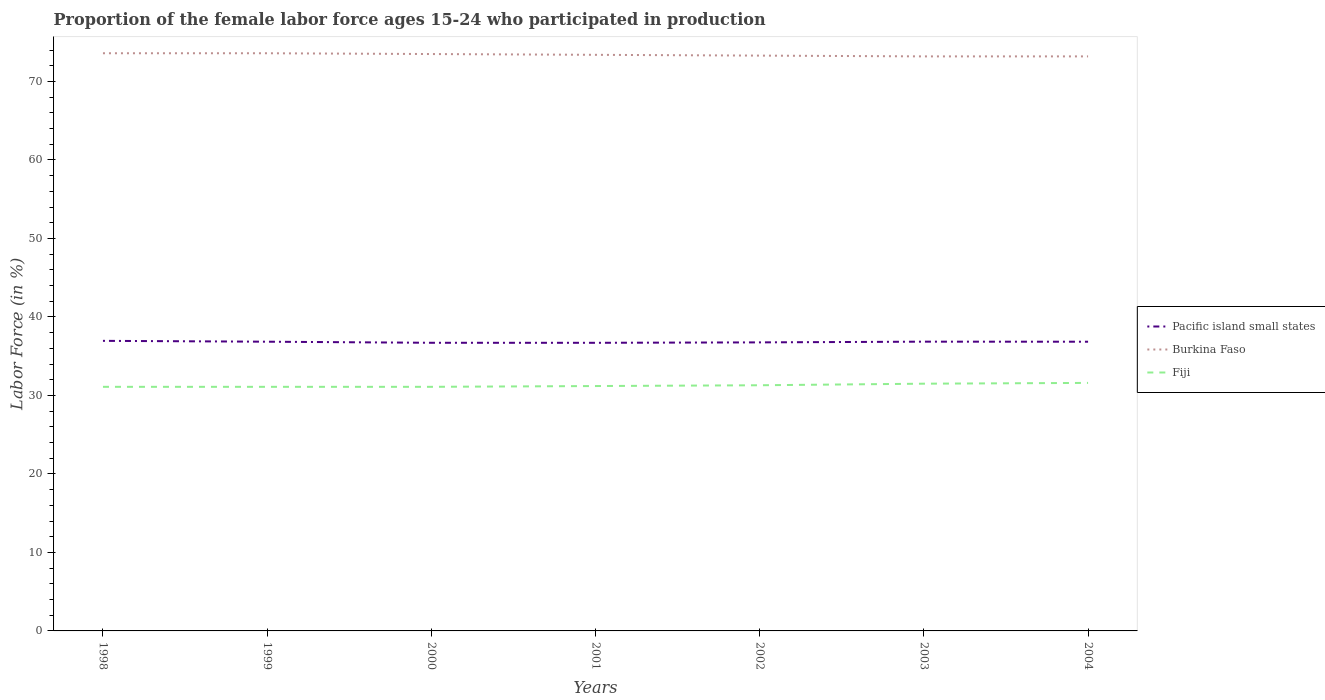How many different coloured lines are there?
Your response must be concise. 3. Across all years, what is the maximum proportion of the female labor force who participated in production in Pacific island small states?
Provide a short and direct response. 36.71. What is the total proportion of the female labor force who participated in production in Pacific island small states in the graph?
Your answer should be compact. 0.01. What is the difference between the highest and the second highest proportion of the female labor force who participated in production in Pacific island small states?
Offer a very short reply. 0.25. Is the proportion of the female labor force who participated in production in Pacific island small states strictly greater than the proportion of the female labor force who participated in production in Burkina Faso over the years?
Your answer should be compact. Yes. Does the graph contain any zero values?
Your answer should be very brief. No. Does the graph contain grids?
Offer a terse response. No. How are the legend labels stacked?
Provide a short and direct response. Vertical. What is the title of the graph?
Offer a terse response. Proportion of the female labor force ages 15-24 who participated in production. What is the label or title of the Y-axis?
Give a very brief answer. Labor Force (in %). What is the Labor Force (in %) in Pacific island small states in 1998?
Give a very brief answer. 36.96. What is the Labor Force (in %) of Burkina Faso in 1998?
Ensure brevity in your answer.  73.6. What is the Labor Force (in %) of Fiji in 1998?
Offer a very short reply. 31.1. What is the Labor Force (in %) in Pacific island small states in 1999?
Your answer should be very brief. 36.85. What is the Labor Force (in %) of Burkina Faso in 1999?
Keep it short and to the point. 73.6. What is the Labor Force (in %) in Fiji in 1999?
Provide a short and direct response. 31.1. What is the Labor Force (in %) of Pacific island small states in 2000?
Offer a terse response. 36.71. What is the Labor Force (in %) in Burkina Faso in 2000?
Offer a very short reply. 73.5. What is the Labor Force (in %) of Fiji in 2000?
Your response must be concise. 31.1. What is the Labor Force (in %) of Pacific island small states in 2001?
Provide a succinct answer. 36.71. What is the Labor Force (in %) in Burkina Faso in 2001?
Make the answer very short. 73.4. What is the Labor Force (in %) of Fiji in 2001?
Your response must be concise. 31.2. What is the Labor Force (in %) in Pacific island small states in 2002?
Offer a very short reply. 36.76. What is the Labor Force (in %) of Burkina Faso in 2002?
Offer a very short reply. 73.3. What is the Labor Force (in %) in Fiji in 2002?
Your answer should be compact. 31.3. What is the Labor Force (in %) in Pacific island small states in 2003?
Your response must be concise. 36.85. What is the Labor Force (in %) in Burkina Faso in 2003?
Keep it short and to the point. 73.2. What is the Labor Force (in %) in Fiji in 2003?
Ensure brevity in your answer.  31.5. What is the Labor Force (in %) in Pacific island small states in 2004?
Ensure brevity in your answer.  36.85. What is the Labor Force (in %) in Burkina Faso in 2004?
Your answer should be very brief. 73.2. What is the Labor Force (in %) in Fiji in 2004?
Provide a succinct answer. 31.6. Across all years, what is the maximum Labor Force (in %) in Pacific island small states?
Ensure brevity in your answer.  36.96. Across all years, what is the maximum Labor Force (in %) in Burkina Faso?
Offer a terse response. 73.6. Across all years, what is the maximum Labor Force (in %) of Fiji?
Keep it short and to the point. 31.6. Across all years, what is the minimum Labor Force (in %) of Pacific island small states?
Offer a very short reply. 36.71. Across all years, what is the minimum Labor Force (in %) in Burkina Faso?
Make the answer very short. 73.2. Across all years, what is the minimum Labor Force (in %) of Fiji?
Make the answer very short. 31.1. What is the total Labor Force (in %) in Pacific island small states in the graph?
Offer a very short reply. 257.69. What is the total Labor Force (in %) of Burkina Faso in the graph?
Provide a short and direct response. 513.8. What is the total Labor Force (in %) of Fiji in the graph?
Offer a very short reply. 218.9. What is the difference between the Labor Force (in %) in Pacific island small states in 1998 and that in 1999?
Your answer should be very brief. 0.11. What is the difference between the Labor Force (in %) of Pacific island small states in 1998 and that in 2000?
Your answer should be very brief. 0.25. What is the difference between the Labor Force (in %) of Pacific island small states in 1998 and that in 2001?
Give a very brief answer. 0.25. What is the difference between the Labor Force (in %) of Pacific island small states in 1998 and that in 2002?
Provide a succinct answer. 0.2. What is the difference between the Labor Force (in %) in Burkina Faso in 1998 and that in 2002?
Offer a very short reply. 0.3. What is the difference between the Labor Force (in %) of Fiji in 1998 and that in 2002?
Give a very brief answer. -0.2. What is the difference between the Labor Force (in %) of Pacific island small states in 1998 and that in 2003?
Ensure brevity in your answer.  0.1. What is the difference between the Labor Force (in %) of Fiji in 1998 and that in 2003?
Offer a very short reply. -0.4. What is the difference between the Labor Force (in %) of Pacific island small states in 1998 and that in 2004?
Your answer should be compact. 0.11. What is the difference between the Labor Force (in %) of Burkina Faso in 1998 and that in 2004?
Make the answer very short. 0.4. What is the difference between the Labor Force (in %) of Fiji in 1998 and that in 2004?
Offer a very short reply. -0.5. What is the difference between the Labor Force (in %) of Pacific island small states in 1999 and that in 2000?
Offer a very short reply. 0.14. What is the difference between the Labor Force (in %) of Burkina Faso in 1999 and that in 2000?
Provide a short and direct response. 0.1. What is the difference between the Labor Force (in %) in Fiji in 1999 and that in 2000?
Make the answer very short. 0. What is the difference between the Labor Force (in %) in Pacific island small states in 1999 and that in 2001?
Ensure brevity in your answer.  0.14. What is the difference between the Labor Force (in %) in Fiji in 1999 and that in 2001?
Offer a terse response. -0.1. What is the difference between the Labor Force (in %) of Pacific island small states in 1999 and that in 2002?
Your response must be concise. 0.09. What is the difference between the Labor Force (in %) in Burkina Faso in 1999 and that in 2002?
Your answer should be very brief. 0.3. What is the difference between the Labor Force (in %) of Fiji in 1999 and that in 2002?
Offer a terse response. -0.2. What is the difference between the Labor Force (in %) in Pacific island small states in 1999 and that in 2003?
Your answer should be compact. -0.01. What is the difference between the Labor Force (in %) of Burkina Faso in 1999 and that in 2003?
Your answer should be compact. 0.4. What is the difference between the Labor Force (in %) of Pacific island small states in 1999 and that in 2004?
Offer a terse response. 0. What is the difference between the Labor Force (in %) of Pacific island small states in 2000 and that in 2001?
Offer a very short reply. 0. What is the difference between the Labor Force (in %) in Burkina Faso in 2000 and that in 2001?
Keep it short and to the point. 0.1. What is the difference between the Labor Force (in %) in Fiji in 2000 and that in 2001?
Your answer should be compact. -0.1. What is the difference between the Labor Force (in %) in Pacific island small states in 2000 and that in 2002?
Your answer should be very brief. -0.05. What is the difference between the Labor Force (in %) in Pacific island small states in 2000 and that in 2003?
Ensure brevity in your answer.  -0.14. What is the difference between the Labor Force (in %) of Burkina Faso in 2000 and that in 2003?
Your answer should be very brief. 0.3. What is the difference between the Labor Force (in %) in Fiji in 2000 and that in 2003?
Provide a short and direct response. -0.4. What is the difference between the Labor Force (in %) in Pacific island small states in 2000 and that in 2004?
Ensure brevity in your answer.  -0.14. What is the difference between the Labor Force (in %) of Burkina Faso in 2000 and that in 2004?
Give a very brief answer. 0.3. What is the difference between the Labor Force (in %) of Pacific island small states in 2001 and that in 2002?
Offer a terse response. -0.05. What is the difference between the Labor Force (in %) in Fiji in 2001 and that in 2002?
Keep it short and to the point. -0.1. What is the difference between the Labor Force (in %) in Pacific island small states in 2001 and that in 2003?
Make the answer very short. -0.15. What is the difference between the Labor Force (in %) of Fiji in 2001 and that in 2003?
Your response must be concise. -0.3. What is the difference between the Labor Force (in %) in Pacific island small states in 2001 and that in 2004?
Keep it short and to the point. -0.14. What is the difference between the Labor Force (in %) of Pacific island small states in 2002 and that in 2003?
Make the answer very short. -0.09. What is the difference between the Labor Force (in %) in Pacific island small states in 2002 and that in 2004?
Your response must be concise. -0.08. What is the difference between the Labor Force (in %) of Fiji in 2002 and that in 2004?
Offer a very short reply. -0.3. What is the difference between the Labor Force (in %) of Pacific island small states in 2003 and that in 2004?
Provide a short and direct response. 0.01. What is the difference between the Labor Force (in %) of Burkina Faso in 2003 and that in 2004?
Your answer should be compact. 0. What is the difference between the Labor Force (in %) in Fiji in 2003 and that in 2004?
Offer a terse response. -0.1. What is the difference between the Labor Force (in %) in Pacific island small states in 1998 and the Labor Force (in %) in Burkina Faso in 1999?
Offer a terse response. -36.64. What is the difference between the Labor Force (in %) of Pacific island small states in 1998 and the Labor Force (in %) of Fiji in 1999?
Provide a succinct answer. 5.86. What is the difference between the Labor Force (in %) in Burkina Faso in 1998 and the Labor Force (in %) in Fiji in 1999?
Ensure brevity in your answer.  42.5. What is the difference between the Labor Force (in %) in Pacific island small states in 1998 and the Labor Force (in %) in Burkina Faso in 2000?
Provide a succinct answer. -36.54. What is the difference between the Labor Force (in %) in Pacific island small states in 1998 and the Labor Force (in %) in Fiji in 2000?
Keep it short and to the point. 5.86. What is the difference between the Labor Force (in %) in Burkina Faso in 1998 and the Labor Force (in %) in Fiji in 2000?
Ensure brevity in your answer.  42.5. What is the difference between the Labor Force (in %) in Pacific island small states in 1998 and the Labor Force (in %) in Burkina Faso in 2001?
Offer a terse response. -36.44. What is the difference between the Labor Force (in %) of Pacific island small states in 1998 and the Labor Force (in %) of Fiji in 2001?
Ensure brevity in your answer.  5.76. What is the difference between the Labor Force (in %) of Burkina Faso in 1998 and the Labor Force (in %) of Fiji in 2001?
Offer a terse response. 42.4. What is the difference between the Labor Force (in %) in Pacific island small states in 1998 and the Labor Force (in %) in Burkina Faso in 2002?
Your response must be concise. -36.34. What is the difference between the Labor Force (in %) in Pacific island small states in 1998 and the Labor Force (in %) in Fiji in 2002?
Keep it short and to the point. 5.66. What is the difference between the Labor Force (in %) in Burkina Faso in 1998 and the Labor Force (in %) in Fiji in 2002?
Your answer should be very brief. 42.3. What is the difference between the Labor Force (in %) in Pacific island small states in 1998 and the Labor Force (in %) in Burkina Faso in 2003?
Offer a terse response. -36.24. What is the difference between the Labor Force (in %) in Pacific island small states in 1998 and the Labor Force (in %) in Fiji in 2003?
Make the answer very short. 5.46. What is the difference between the Labor Force (in %) in Burkina Faso in 1998 and the Labor Force (in %) in Fiji in 2003?
Offer a very short reply. 42.1. What is the difference between the Labor Force (in %) of Pacific island small states in 1998 and the Labor Force (in %) of Burkina Faso in 2004?
Offer a very short reply. -36.24. What is the difference between the Labor Force (in %) of Pacific island small states in 1998 and the Labor Force (in %) of Fiji in 2004?
Ensure brevity in your answer.  5.36. What is the difference between the Labor Force (in %) of Burkina Faso in 1998 and the Labor Force (in %) of Fiji in 2004?
Your answer should be compact. 42. What is the difference between the Labor Force (in %) of Pacific island small states in 1999 and the Labor Force (in %) of Burkina Faso in 2000?
Your answer should be very brief. -36.65. What is the difference between the Labor Force (in %) in Pacific island small states in 1999 and the Labor Force (in %) in Fiji in 2000?
Your answer should be compact. 5.75. What is the difference between the Labor Force (in %) in Burkina Faso in 1999 and the Labor Force (in %) in Fiji in 2000?
Offer a terse response. 42.5. What is the difference between the Labor Force (in %) in Pacific island small states in 1999 and the Labor Force (in %) in Burkina Faso in 2001?
Your answer should be compact. -36.55. What is the difference between the Labor Force (in %) in Pacific island small states in 1999 and the Labor Force (in %) in Fiji in 2001?
Ensure brevity in your answer.  5.65. What is the difference between the Labor Force (in %) of Burkina Faso in 1999 and the Labor Force (in %) of Fiji in 2001?
Provide a succinct answer. 42.4. What is the difference between the Labor Force (in %) in Pacific island small states in 1999 and the Labor Force (in %) in Burkina Faso in 2002?
Your answer should be compact. -36.45. What is the difference between the Labor Force (in %) of Pacific island small states in 1999 and the Labor Force (in %) of Fiji in 2002?
Give a very brief answer. 5.55. What is the difference between the Labor Force (in %) in Burkina Faso in 1999 and the Labor Force (in %) in Fiji in 2002?
Your answer should be compact. 42.3. What is the difference between the Labor Force (in %) in Pacific island small states in 1999 and the Labor Force (in %) in Burkina Faso in 2003?
Make the answer very short. -36.35. What is the difference between the Labor Force (in %) in Pacific island small states in 1999 and the Labor Force (in %) in Fiji in 2003?
Give a very brief answer. 5.35. What is the difference between the Labor Force (in %) of Burkina Faso in 1999 and the Labor Force (in %) of Fiji in 2003?
Provide a short and direct response. 42.1. What is the difference between the Labor Force (in %) in Pacific island small states in 1999 and the Labor Force (in %) in Burkina Faso in 2004?
Keep it short and to the point. -36.35. What is the difference between the Labor Force (in %) of Pacific island small states in 1999 and the Labor Force (in %) of Fiji in 2004?
Offer a very short reply. 5.25. What is the difference between the Labor Force (in %) of Burkina Faso in 1999 and the Labor Force (in %) of Fiji in 2004?
Your answer should be very brief. 42. What is the difference between the Labor Force (in %) of Pacific island small states in 2000 and the Labor Force (in %) of Burkina Faso in 2001?
Ensure brevity in your answer.  -36.69. What is the difference between the Labor Force (in %) in Pacific island small states in 2000 and the Labor Force (in %) in Fiji in 2001?
Your answer should be compact. 5.51. What is the difference between the Labor Force (in %) of Burkina Faso in 2000 and the Labor Force (in %) of Fiji in 2001?
Your response must be concise. 42.3. What is the difference between the Labor Force (in %) of Pacific island small states in 2000 and the Labor Force (in %) of Burkina Faso in 2002?
Give a very brief answer. -36.59. What is the difference between the Labor Force (in %) of Pacific island small states in 2000 and the Labor Force (in %) of Fiji in 2002?
Provide a succinct answer. 5.41. What is the difference between the Labor Force (in %) of Burkina Faso in 2000 and the Labor Force (in %) of Fiji in 2002?
Your answer should be compact. 42.2. What is the difference between the Labor Force (in %) of Pacific island small states in 2000 and the Labor Force (in %) of Burkina Faso in 2003?
Give a very brief answer. -36.49. What is the difference between the Labor Force (in %) of Pacific island small states in 2000 and the Labor Force (in %) of Fiji in 2003?
Give a very brief answer. 5.21. What is the difference between the Labor Force (in %) in Burkina Faso in 2000 and the Labor Force (in %) in Fiji in 2003?
Your response must be concise. 42. What is the difference between the Labor Force (in %) of Pacific island small states in 2000 and the Labor Force (in %) of Burkina Faso in 2004?
Offer a terse response. -36.49. What is the difference between the Labor Force (in %) in Pacific island small states in 2000 and the Labor Force (in %) in Fiji in 2004?
Offer a terse response. 5.11. What is the difference between the Labor Force (in %) of Burkina Faso in 2000 and the Labor Force (in %) of Fiji in 2004?
Your answer should be compact. 41.9. What is the difference between the Labor Force (in %) of Pacific island small states in 2001 and the Labor Force (in %) of Burkina Faso in 2002?
Keep it short and to the point. -36.59. What is the difference between the Labor Force (in %) of Pacific island small states in 2001 and the Labor Force (in %) of Fiji in 2002?
Keep it short and to the point. 5.41. What is the difference between the Labor Force (in %) of Burkina Faso in 2001 and the Labor Force (in %) of Fiji in 2002?
Keep it short and to the point. 42.1. What is the difference between the Labor Force (in %) in Pacific island small states in 2001 and the Labor Force (in %) in Burkina Faso in 2003?
Offer a terse response. -36.49. What is the difference between the Labor Force (in %) in Pacific island small states in 2001 and the Labor Force (in %) in Fiji in 2003?
Make the answer very short. 5.21. What is the difference between the Labor Force (in %) in Burkina Faso in 2001 and the Labor Force (in %) in Fiji in 2003?
Offer a terse response. 41.9. What is the difference between the Labor Force (in %) of Pacific island small states in 2001 and the Labor Force (in %) of Burkina Faso in 2004?
Offer a very short reply. -36.49. What is the difference between the Labor Force (in %) in Pacific island small states in 2001 and the Labor Force (in %) in Fiji in 2004?
Ensure brevity in your answer.  5.11. What is the difference between the Labor Force (in %) of Burkina Faso in 2001 and the Labor Force (in %) of Fiji in 2004?
Your answer should be compact. 41.8. What is the difference between the Labor Force (in %) of Pacific island small states in 2002 and the Labor Force (in %) of Burkina Faso in 2003?
Provide a short and direct response. -36.44. What is the difference between the Labor Force (in %) of Pacific island small states in 2002 and the Labor Force (in %) of Fiji in 2003?
Make the answer very short. 5.26. What is the difference between the Labor Force (in %) in Burkina Faso in 2002 and the Labor Force (in %) in Fiji in 2003?
Make the answer very short. 41.8. What is the difference between the Labor Force (in %) of Pacific island small states in 2002 and the Labor Force (in %) of Burkina Faso in 2004?
Your response must be concise. -36.44. What is the difference between the Labor Force (in %) of Pacific island small states in 2002 and the Labor Force (in %) of Fiji in 2004?
Your answer should be very brief. 5.16. What is the difference between the Labor Force (in %) of Burkina Faso in 2002 and the Labor Force (in %) of Fiji in 2004?
Offer a terse response. 41.7. What is the difference between the Labor Force (in %) in Pacific island small states in 2003 and the Labor Force (in %) in Burkina Faso in 2004?
Make the answer very short. -36.35. What is the difference between the Labor Force (in %) in Pacific island small states in 2003 and the Labor Force (in %) in Fiji in 2004?
Your answer should be compact. 5.25. What is the difference between the Labor Force (in %) in Burkina Faso in 2003 and the Labor Force (in %) in Fiji in 2004?
Ensure brevity in your answer.  41.6. What is the average Labor Force (in %) in Pacific island small states per year?
Provide a short and direct response. 36.81. What is the average Labor Force (in %) in Burkina Faso per year?
Your response must be concise. 73.4. What is the average Labor Force (in %) of Fiji per year?
Your answer should be compact. 31.27. In the year 1998, what is the difference between the Labor Force (in %) in Pacific island small states and Labor Force (in %) in Burkina Faso?
Your response must be concise. -36.64. In the year 1998, what is the difference between the Labor Force (in %) in Pacific island small states and Labor Force (in %) in Fiji?
Offer a terse response. 5.86. In the year 1998, what is the difference between the Labor Force (in %) of Burkina Faso and Labor Force (in %) of Fiji?
Ensure brevity in your answer.  42.5. In the year 1999, what is the difference between the Labor Force (in %) in Pacific island small states and Labor Force (in %) in Burkina Faso?
Offer a very short reply. -36.75. In the year 1999, what is the difference between the Labor Force (in %) in Pacific island small states and Labor Force (in %) in Fiji?
Offer a very short reply. 5.75. In the year 1999, what is the difference between the Labor Force (in %) in Burkina Faso and Labor Force (in %) in Fiji?
Your answer should be compact. 42.5. In the year 2000, what is the difference between the Labor Force (in %) in Pacific island small states and Labor Force (in %) in Burkina Faso?
Offer a very short reply. -36.79. In the year 2000, what is the difference between the Labor Force (in %) in Pacific island small states and Labor Force (in %) in Fiji?
Offer a terse response. 5.61. In the year 2000, what is the difference between the Labor Force (in %) in Burkina Faso and Labor Force (in %) in Fiji?
Offer a terse response. 42.4. In the year 2001, what is the difference between the Labor Force (in %) of Pacific island small states and Labor Force (in %) of Burkina Faso?
Your answer should be compact. -36.69. In the year 2001, what is the difference between the Labor Force (in %) in Pacific island small states and Labor Force (in %) in Fiji?
Your answer should be very brief. 5.51. In the year 2001, what is the difference between the Labor Force (in %) in Burkina Faso and Labor Force (in %) in Fiji?
Provide a short and direct response. 42.2. In the year 2002, what is the difference between the Labor Force (in %) in Pacific island small states and Labor Force (in %) in Burkina Faso?
Your response must be concise. -36.54. In the year 2002, what is the difference between the Labor Force (in %) in Pacific island small states and Labor Force (in %) in Fiji?
Your response must be concise. 5.46. In the year 2003, what is the difference between the Labor Force (in %) of Pacific island small states and Labor Force (in %) of Burkina Faso?
Keep it short and to the point. -36.35. In the year 2003, what is the difference between the Labor Force (in %) in Pacific island small states and Labor Force (in %) in Fiji?
Make the answer very short. 5.35. In the year 2003, what is the difference between the Labor Force (in %) in Burkina Faso and Labor Force (in %) in Fiji?
Offer a very short reply. 41.7. In the year 2004, what is the difference between the Labor Force (in %) of Pacific island small states and Labor Force (in %) of Burkina Faso?
Ensure brevity in your answer.  -36.35. In the year 2004, what is the difference between the Labor Force (in %) in Pacific island small states and Labor Force (in %) in Fiji?
Offer a very short reply. 5.25. In the year 2004, what is the difference between the Labor Force (in %) in Burkina Faso and Labor Force (in %) in Fiji?
Make the answer very short. 41.6. What is the ratio of the Labor Force (in %) in Pacific island small states in 1998 to that in 1999?
Make the answer very short. 1. What is the ratio of the Labor Force (in %) of Burkina Faso in 1998 to that in 1999?
Provide a short and direct response. 1. What is the ratio of the Labor Force (in %) of Pacific island small states in 1998 to that in 2000?
Provide a succinct answer. 1.01. What is the ratio of the Labor Force (in %) of Burkina Faso in 1998 to that in 2000?
Provide a short and direct response. 1. What is the ratio of the Labor Force (in %) in Fiji in 1998 to that in 2000?
Provide a succinct answer. 1. What is the ratio of the Labor Force (in %) in Pacific island small states in 1998 to that in 2001?
Your answer should be very brief. 1.01. What is the ratio of the Labor Force (in %) of Burkina Faso in 1998 to that in 2001?
Your answer should be compact. 1. What is the ratio of the Labor Force (in %) of Fiji in 1998 to that in 2001?
Make the answer very short. 1. What is the ratio of the Labor Force (in %) of Fiji in 1998 to that in 2003?
Offer a terse response. 0.99. What is the ratio of the Labor Force (in %) of Burkina Faso in 1998 to that in 2004?
Provide a succinct answer. 1.01. What is the ratio of the Labor Force (in %) of Fiji in 1998 to that in 2004?
Give a very brief answer. 0.98. What is the ratio of the Labor Force (in %) in Pacific island small states in 1999 to that in 2000?
Ensure brevity in your answer.  1. What is the ratio of the Labor Force (in %) of Burkina Faso in 1999 to that in 2000?
Give a very brief answer. 1. What is the ratio of the Labor Force (in %) in Fiji in 1999 to that in 2000?
Offer a very short reply. 1. What is the ratio of the Labor Force (in %) of Pacific island small states in 1999 to that in 2001?
Offer a very short reply. 1. What is the ratio of the Labor Force (in %) of Burkina Faso in 1999 to that in 2001?
Your response must be concise. 1. What is the ratio of the Labor Force (in %) of Pacific island small states in 1999 to that in 2002?
Ensure brevity in your answer.  1. What is the ratio of the Labor Force (in %) in Burkina Faso in 1999 to that in 2003?
Provide a short and direct response. 1.01. What is the ratio of the Labor Force (in %) of Fiji in 1999 to that in 2003?
Keep it short and to the point. 0.99. What is the ratio of the Labor Force (in %) of Pacific island small states in 1999 to that in 2004?
Your answer should be compact. 1. What is the ratio of the Labor Force (in %) of Burkina Faso in 1999 to that in 2004?
Your answer should be compact. 1.01. What is the ratio of the Labor Force (in %) in Fiji in 1999 to that in 2004?
Your answer should be very brief. 0.98. What is the ratio of the Labor Force (in %) of Fiji in 2000 to that in 2002?
Give a very brief answer. 0.99. What is the ratio of the Labor Force (in %) in Pacific island small states in 2000 to that in 2003?
Your answer should be very brief. 1. What is the ratio of the Labor Force (in %) in Burkina Faso in 2000 to that in 2003?
Give a very brief answer. 1. What is the ratio of the Labor Force (in %) of Fiji in 2000 to that in 2003?
Your answer should be compact. 0.99. What is the ratio of the Labor Force (in %) in Pacific island small states in 2000 to that in 2004?
Your response must be concise. 1. What is the ratio of the Labor Force (in %) in Fiji in 2000 to that in 2004?
Provide a succinct answer. 0.98. What is the ratio of the Labor Force (in %) in Fiji in 2001 to that in 2003?
Offer a terse response. 0.99. What is the ratio of the Labor Force (in %) in Pacific island small states in 2001 to that in 2004?
Provide a succinct answer. 1. What is the ratio of the Labor Force (in %) of Burkina Faso in 2001 to that in 2004?
Offer a very short reply. 1. What is the ratio of the Labor Force (in %) of Fiji in 2001 to that in 2004?
Your answer should be very brief. 0.99. What is the ratio of the Labor Force (in %) of Pacific island small states in 2002 to that in 2003?
Your answer should be compact. 1. What is the ratio of the Labor Force (in %) of Burkina Faso in 2002 to that in 2003?
Offer a very short reply. 1. What is the ratio of the Labor Force (in %) in Burkina Faso in 2002 to that in 2004?
Offer a very short reply. 1. What is the ratio of the Labor Force (in %) in Pacific island small states in 2003 to that in 2004?
Your response must be concise. 1. What is the difference between the highest and the second highest Labor Force (in %) of Pacific island small states?
Your answer should be very brief. 0.1. What is the difference between the highest and the second highest Labor Force (in %) of Burkina Faso?
Offer a very short reply. 0. What is the difference between the highest and the lowest Labor Force (in %) of Pacific island small states?
Offer a terse response. 0.25. 